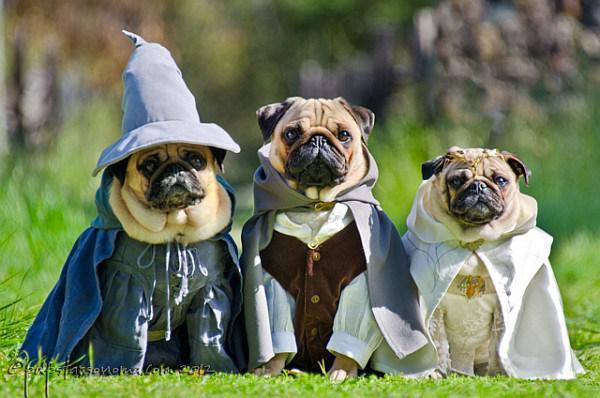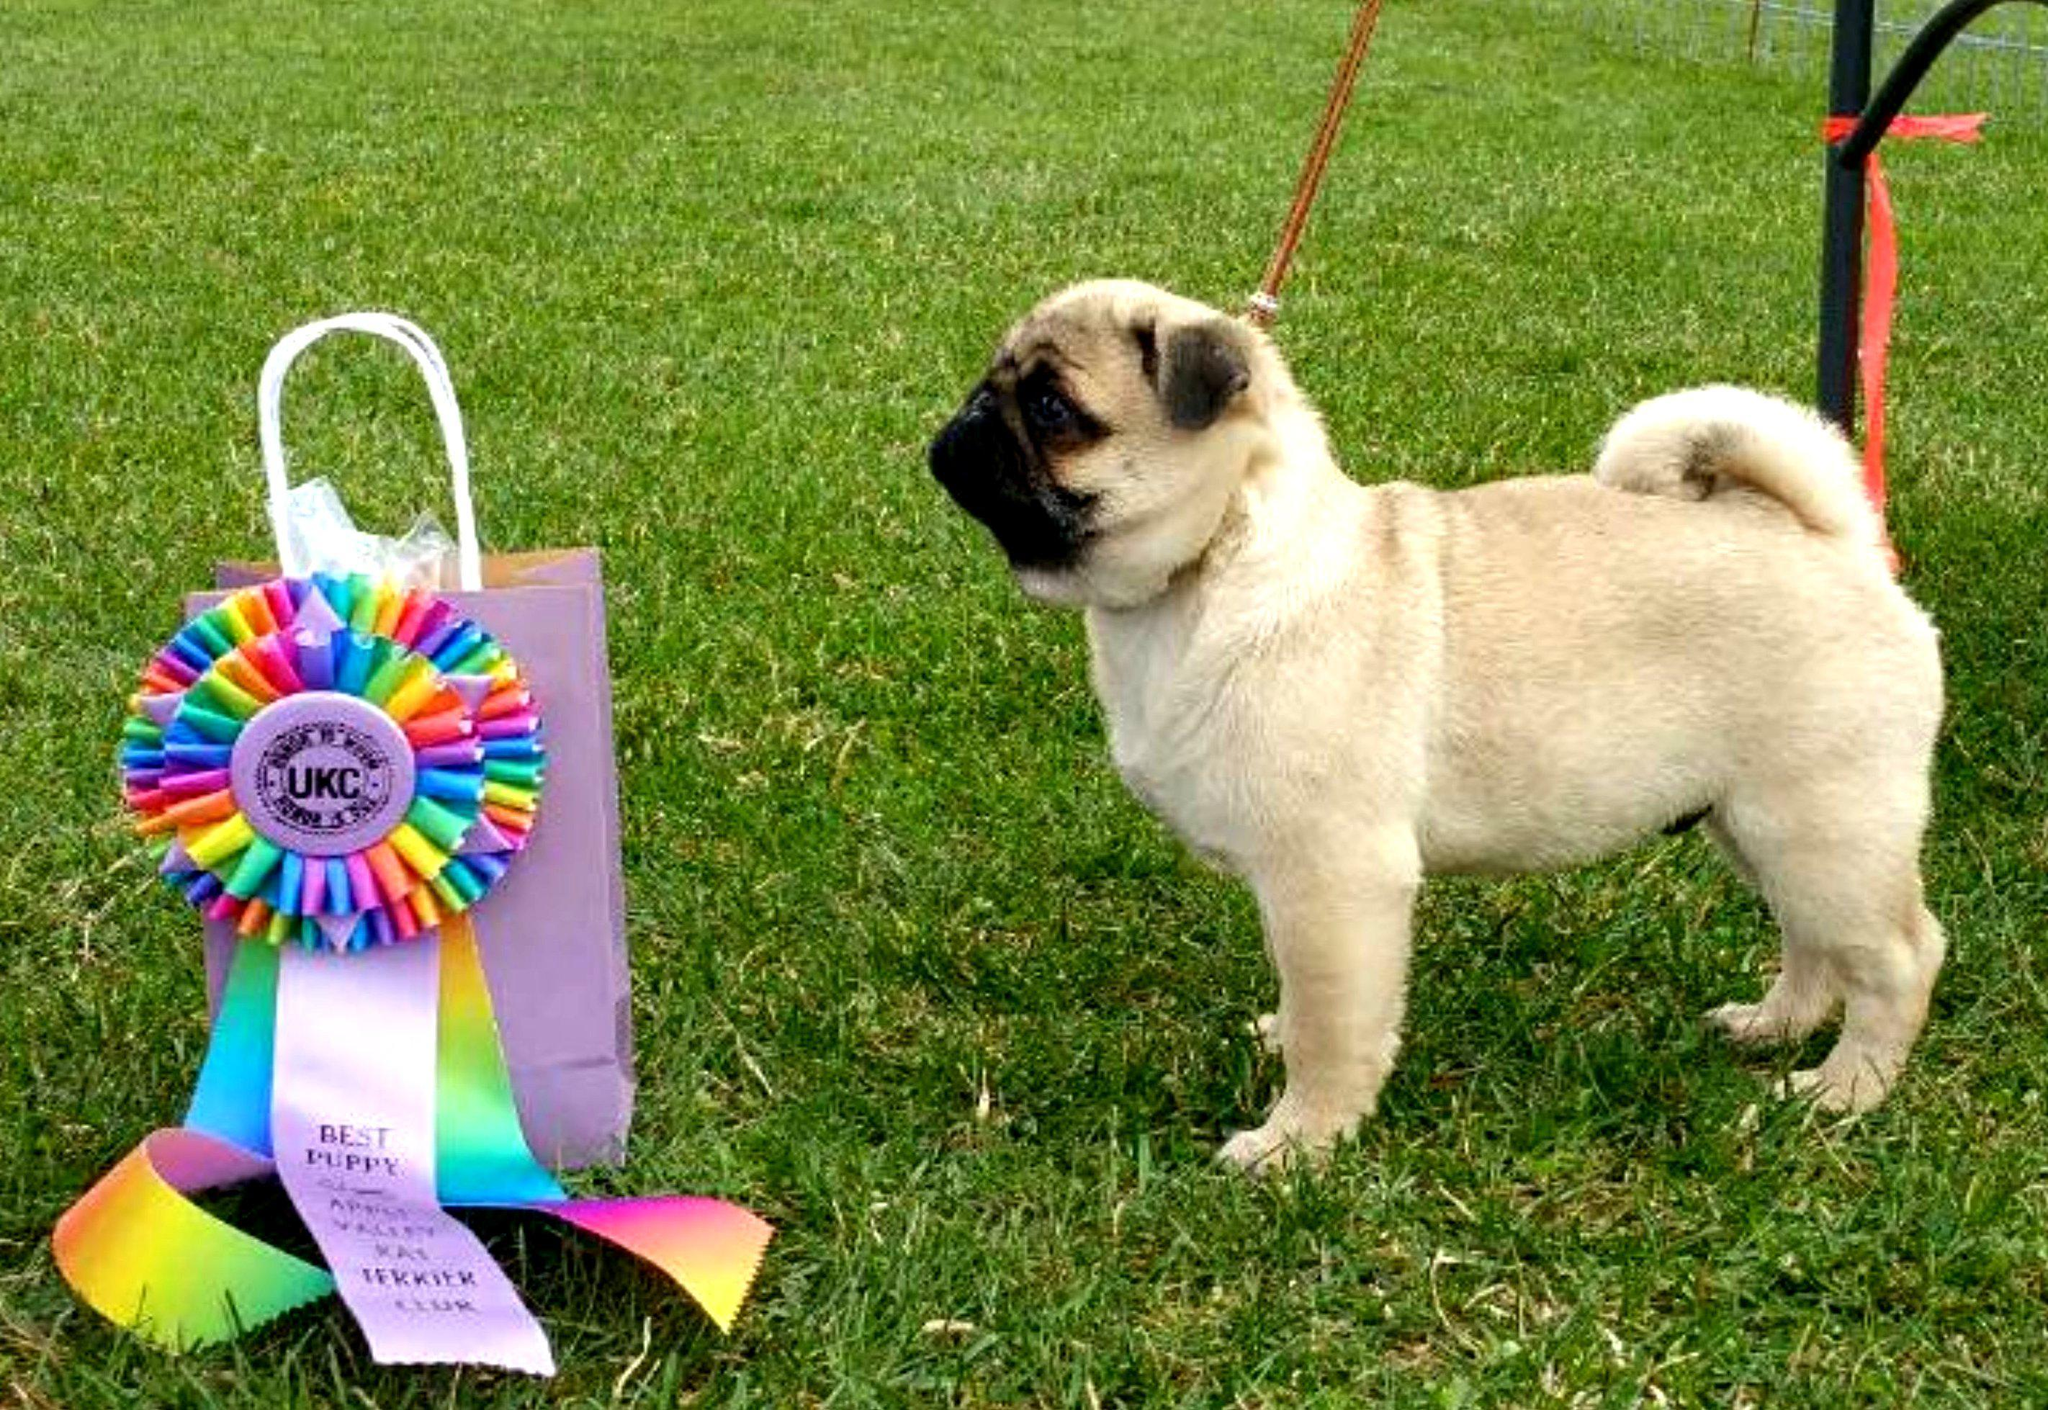The first image is the image on the left, the second image is the image on the right. Given the left and right images, does the statement "One of the four pugs is wearing a hat." hold true? Answer yes or no. Yes. The first image is the image on the left, the second image is the image on the right. Given the left and right images, does the statement "The right image includes at least one standing beige pug on a leash, and the left image features three forward-facing beige pugs wearing some type of attire." hold true? Answer yes or no. Yes. 